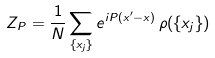<formula> <loc_0><loc_0><loc_500><loc_500>Z _ { P } = \frac { 1 } { N } \sum _ { \{ x _ { j } \} } e ^ { i P ( x ^ { \prime } - x ) } \, \rho ( \{ x _ { j } \} )</formula> 